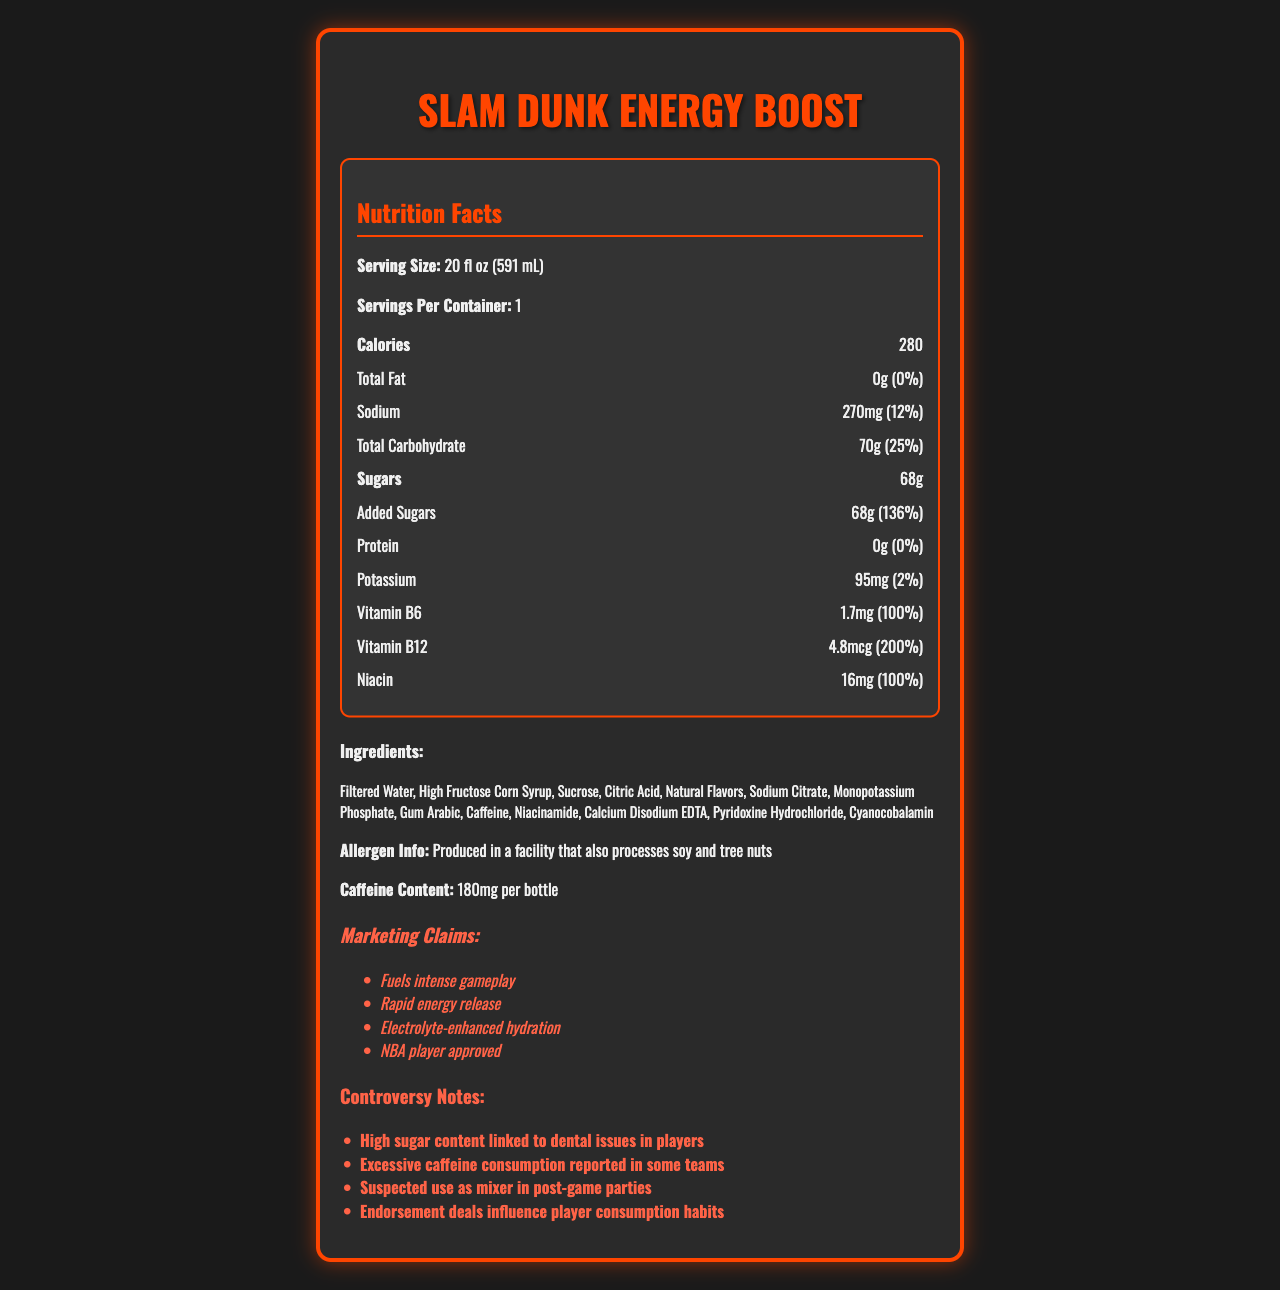who is the manufacturer of Slam Dunk Energy Boost? The document does not provide any information about the manufacturer of Slam Dunk Energy Boost.
Answer: I don't know what is the serving size for Slam Dunk Energy Boost? The document specifies that the serving size for Slam Dunk Energy Boost is 20 fl oz (591 mL).
Answer: 20 fl oz (591 mL) how much sodium is in each serving of Slam Dunk Energy Boost? The document indicates that each serving of Slam Dunk Energy Boost contains 270mg of sodium.
Answer: 270mg what is the daily value percentage of added sugars in Slam Dunk Energy Boost? The document shows that the daily value percentage of added sugars in Slam Dunk Energy Boost is 136%.
Answer: 136% what are the three vitamins included in the nutrition facts of Slam Dunk Energy Boost? The document lists Vitamin B6, Vitamin B12, and Niacin in the nutrition facts section.
Answer: Vitamin B6, Vitamin B12, Niacin which of the following claims is not made in the marketing claims section? A. Fuels intense gameplay B. Helps with weight loss C. Rapid energy release D. Electrolyte-enhanced hydration The marketing claims section mentions "Fuels intense gameplay," "Rapid energy release," and "Electrolyte-enhanced hydration," but does not mention "Helps with weight loss."
Answer: B how many grams of protein does Slam Dunk Energy Boost contain? The document specifies that Slam Dunk Energy Boost contains 0g of protein.
Answer: 0g what is the caffeine content per bottle of Slam Dunk Energy Boost? The document notes that the caffeine content per bottle of Slam Dunk Energy Boost is 180mg.
Answer: 180mg what health issue is mentioned in the controversy notes related to the high sugar content? The controversy notes mention that the high sugar content in Slam Dunk Energy Boost is linked to dental issues in players.
Answer: Dental issues which vitamin has the highest daily value percentage in Slam Dunk Energy Boost? A. Vitamin B6 B. Vitamin B12 C. Potassium D. Niacin Vitamin B12 has the highest daily value percentage at 200%, compared to Vitamin B6 and Niacin both at 100%, and Potassium at 2%.
Answer: B is there any mention of performance enhancement for basketball players? The document includes a marketing claim that it is "NBA player approved" and claims to fuel intense gameplay.
Answer: Yes describe the main features and concerns of Slam Dunk Energy Boost. The main features include its high calorie, carbohydrate, and caffeine content, along with significant vitamins. Concerning issues relate to the high sugar content and caffeine consumption, implications for player health, and off-court use.
Answer: Slam Dunk Energy Boost is a high-calorie sports drink with a serving size of 20 fl oz (591 mL) and 280 calories. It contains 270mg of sodium, 70g of total carbohydrates, including 68g of added sugars with a daily value of 136%, and 180mg of caffeine per bottle. The drink also provides significant amounts of Vitamin B6, Vitamin B12, and Niacin. However, it contains no fat or protein. Ingredients include filtered water, high fructose corn syrup, sucrose, and others. The product has marketing claims such as fueling intense gameplay and providing rapid energy release. Concerns include high sugar content leading to dental issues, excessive caffeine consumption in some teams, its use as a mixer in post-game parties, and endorsement influence on player consumption habits. how many grams of sugars are in one serving of Slam Dunk Energy Boost? The document notes that there are 68g of sugars in one serving of Slam Dunk Energy Boost.
Answer: 68g does Slam Dunk Energy Boost contain any allergens directly? The document notes that it is "Produced in a facility that also processes soy and tree nuts," but does not list any direct allergens in the ingredients of the drink.
Answer: No 